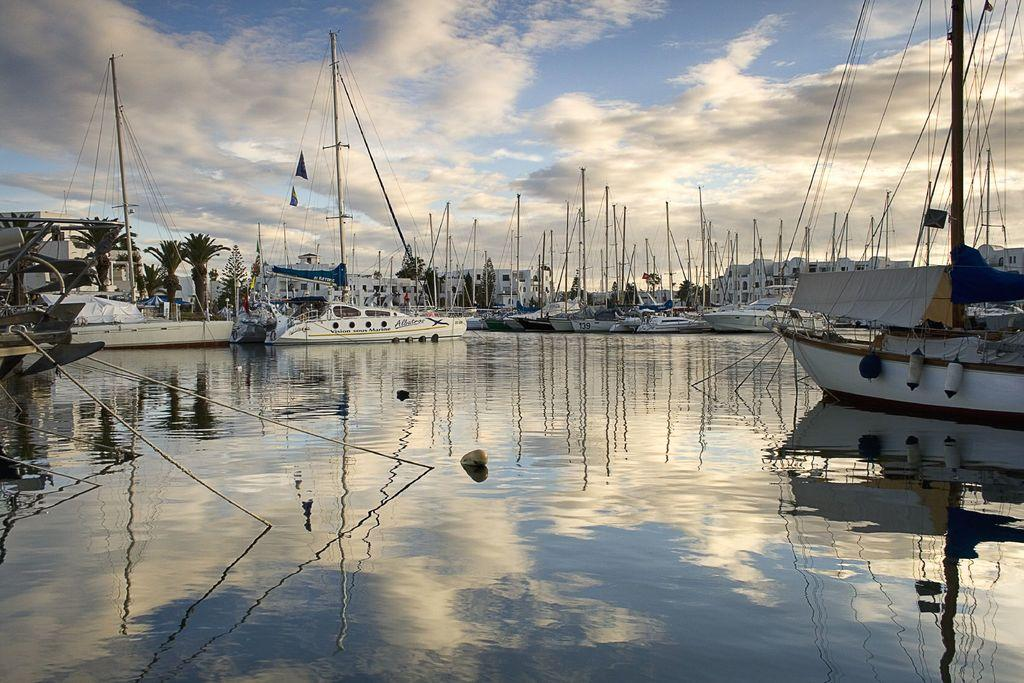What is floating on the water in the image? There are ships floating on the water in the image. What can be seen behind the ships? There are houses and trees behind the ships. What type of stew is being cooked in the picture? There is no picture or stew present in the image; it features ships floating on the water with houses and trees in the background. 